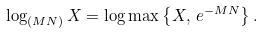<formula> <loc_0><loc_0><loc_500><loc_500>\log _ { ( M N ) } X = \log \max \left \{ X , \, e ^ { - M N } \right \} .</formula> 